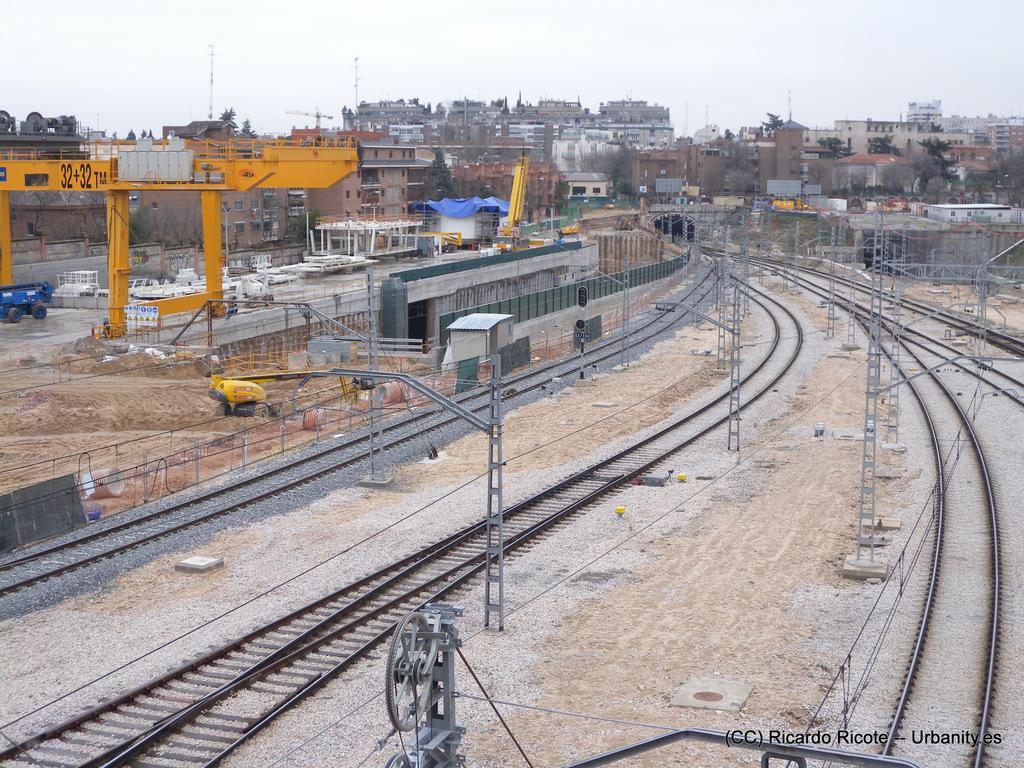Provide a one-sentence caption for the provided image. A large yellow metal structure is marked 32+32 TM. 